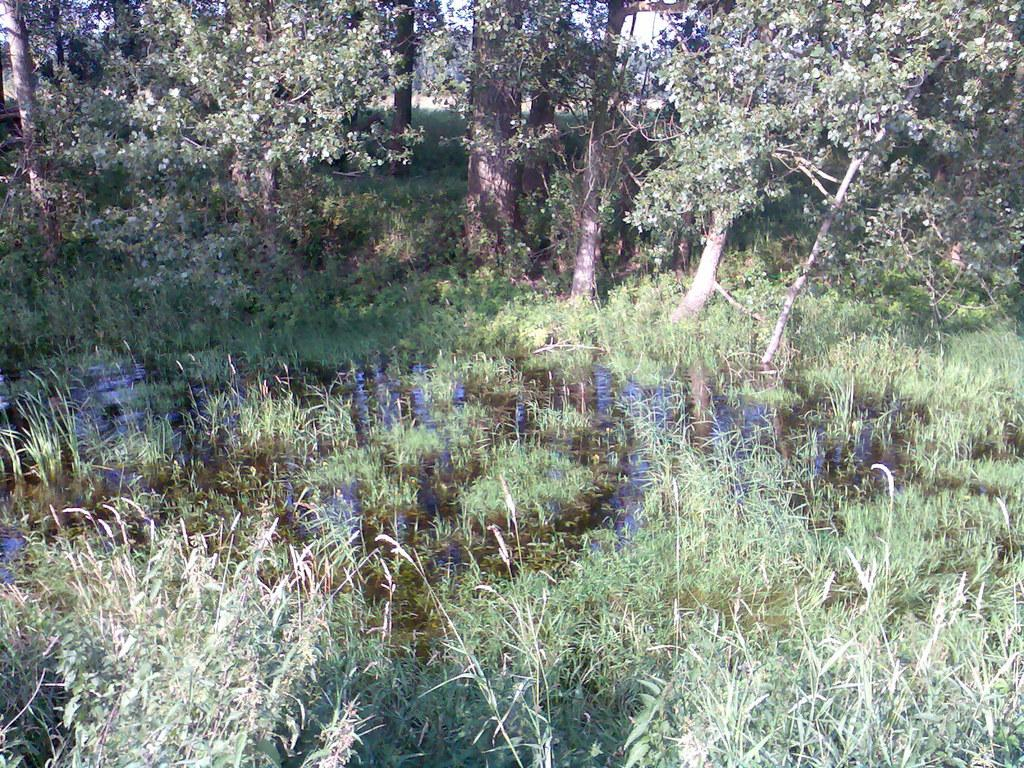What type of vegetation can be seen in the image? There are trees and plants in the image. What natural element is visible in the image? There is water visible in the image. Where is the flock of birds sitting on the sofa in the image? There is no flock of birds or sofa present in the image. 